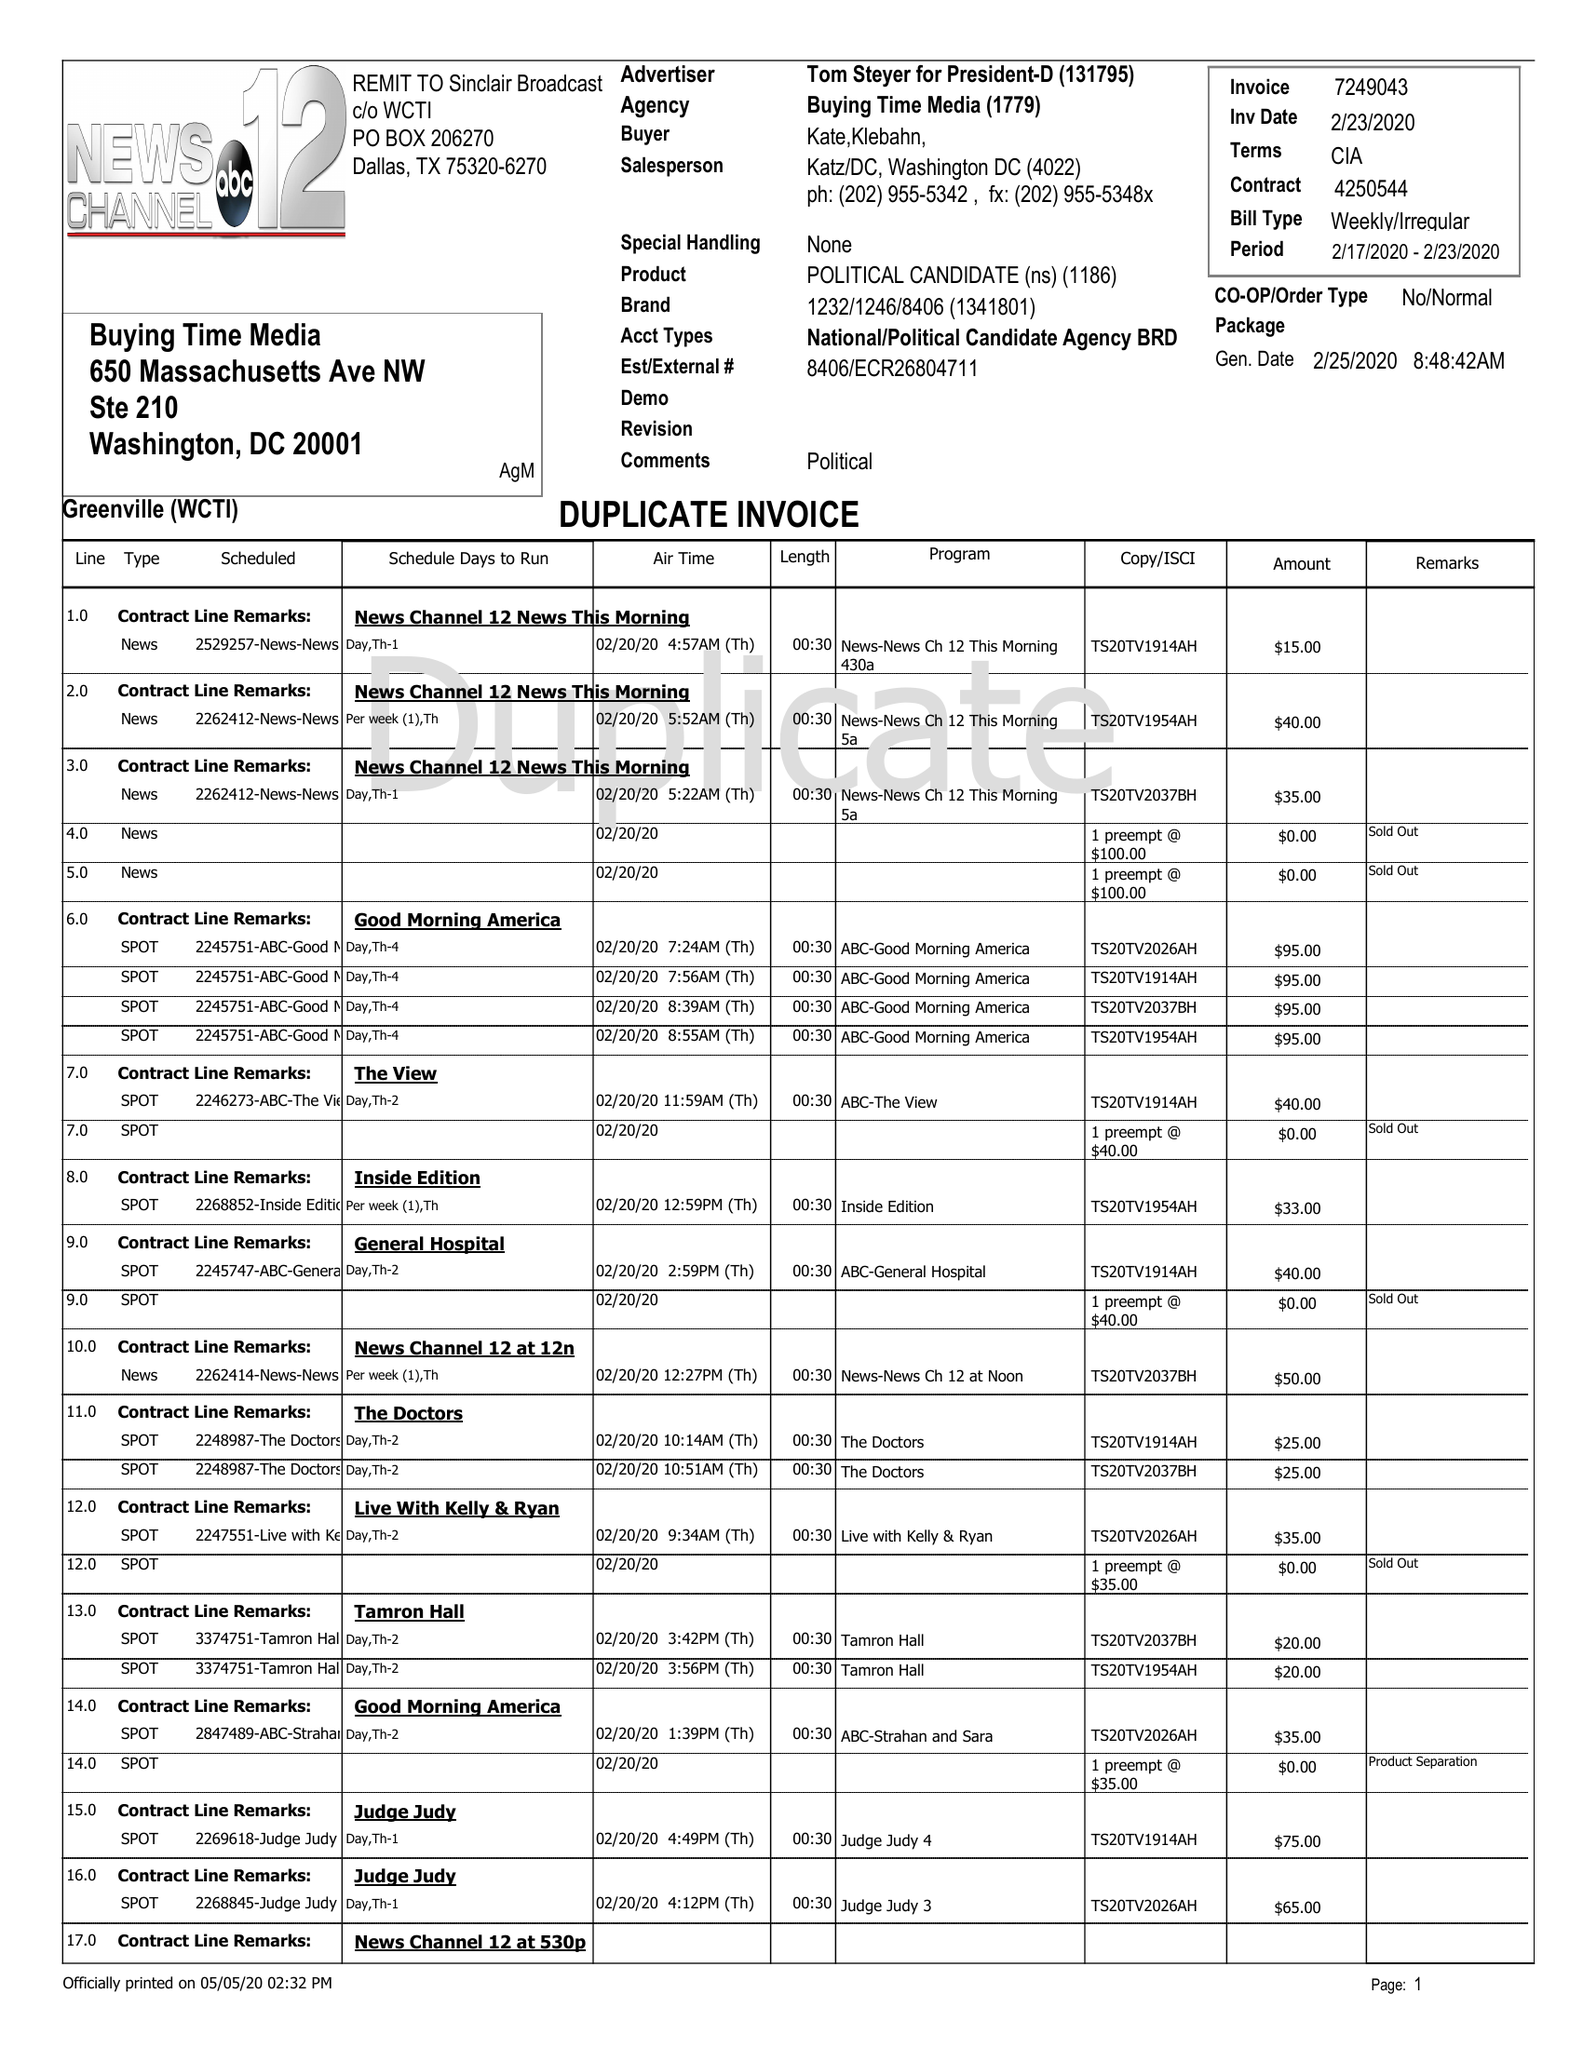What is the value for the flight_from?
Answer the question using a single word or phrase. 02/17/20 